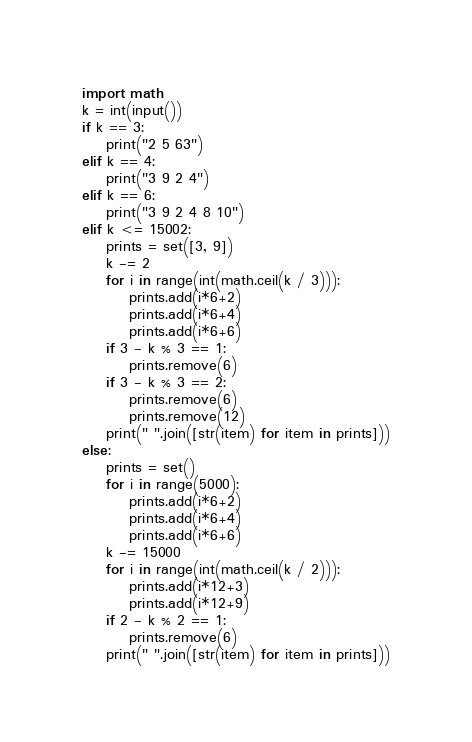Convert code to text. <code><loc_0><loc_0><loc_500><loc_500><_Python_>import math
k = int(input())
if k == 3:
    print("2 5 63")
elif k == 4:
    print("3 9 2 4")
elif k == 6:
    print("3 9 2 4 8 10")
elif k <= 15002:
    prints = set([3, 9]) 
    k -= 2
    for i in range(int(math.ceil(k / 3))):
        prints.add(i*6+2)
        prints.add(i*6+4)
        prints.add(i*6+6)
    if 3 - k % 3 == 1:
        prints.remove(6)
    if 3 - k % 3 == 2:
        prints.remove(6)
        prints.remove(12)
    print(" ".join([str(item) for item in prints]))
else:
    prints = set() 
    for i in range(5000):
        prints.add(i*6+2)
        prints.add(i*6+4)
        prints.add(i*6+6)
    k -= 15000
    for i in range(int(math.ceil(k / 2))):
        prints.add(i*12+3)
        prints.add(i*12+9)
    if 2 - k % 2 == 1:
        prints.remove(6)
    print(" ".join([str(item) for item in prints]))</code> 